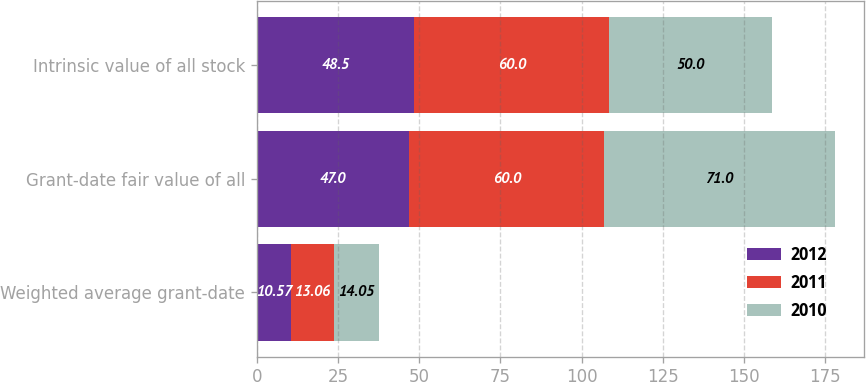<chart> <loc_0><loc_0><loc_500><loc_500><stacked_bar_chart><ecel><fcel>Weighted average grant-date<fcel>Grant-date fair value of all<fcel>Intrinsic value of all stock<nl><fcel>2012<fcel>10.57<fcel>47<fcel>48.5<nl><fcel>2011<fcel>13.06<fcel>60<fcel>60<nl><fcel>2010<fcel>14.05<fcel>71<fcel>50<nl></chart> 